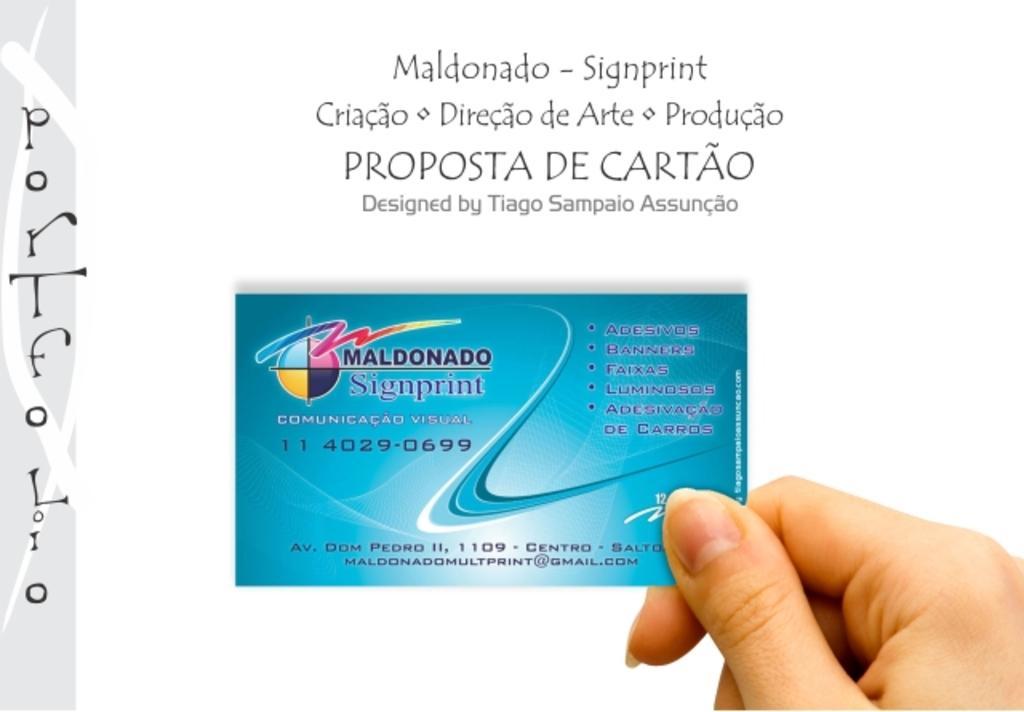In one or two sentences, can you explain what this image depicts? In this picture we can see a person hand holding a card and we can see some text. 